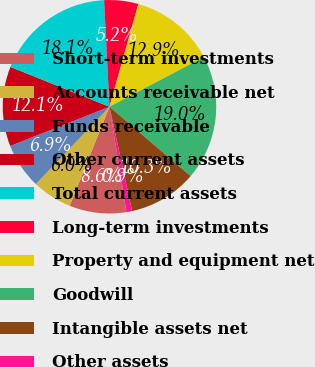Convert chart to OTSL. <chart><loc_0><loc_0><loc_500><loc_500><pie_chart><fcel>Short-term investments<fcel>Accounts receivable net<fcel>Funds receivable<fcel>Other current assets<fcel>Total current assets<fcel>Long-term investments<fcel>Property and equipment net<fcel>Goodwill<fcel>Intangible assets net<fcel>Other assets<nl><fcel>8.62%<fcel>6.03%<fcel>6.9%<fcel>12.07%<fcel>18.1%<fcel>5.17%<fcel>12.93%<fcel>18.96%<fcel>10.34%<fcel>0.86%<nl></chart> 